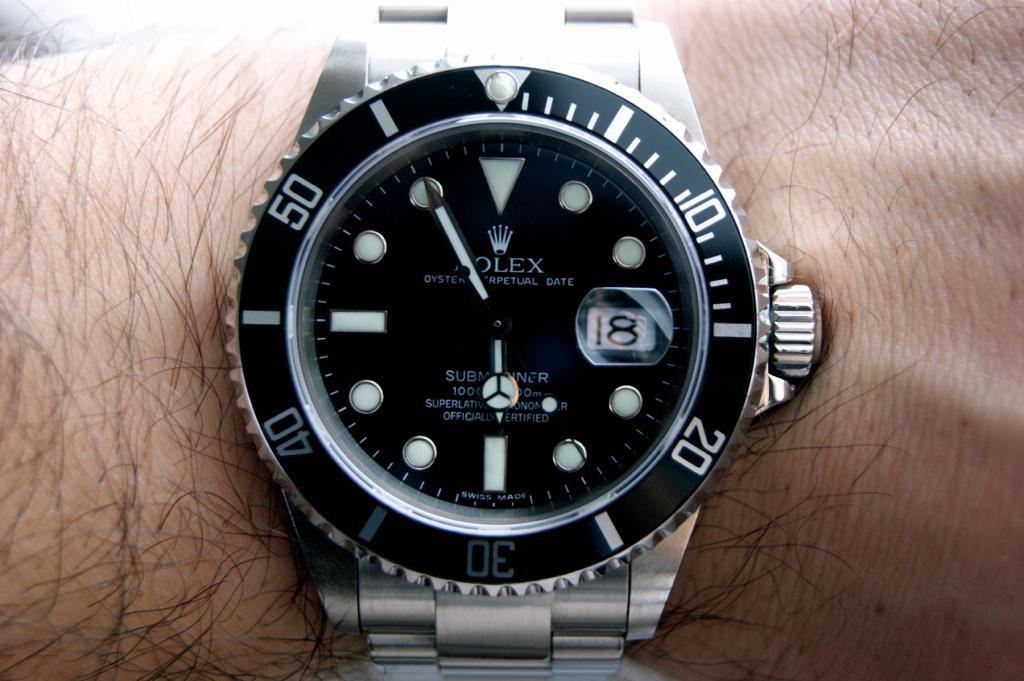What object is featured in the image? There is a watch in the image. Where is the watch located? The watch is on a hand. What type of powder is being used to create a smile on the watch in the image? There is no powder or smile present in the image; it features a watch on a hand. 